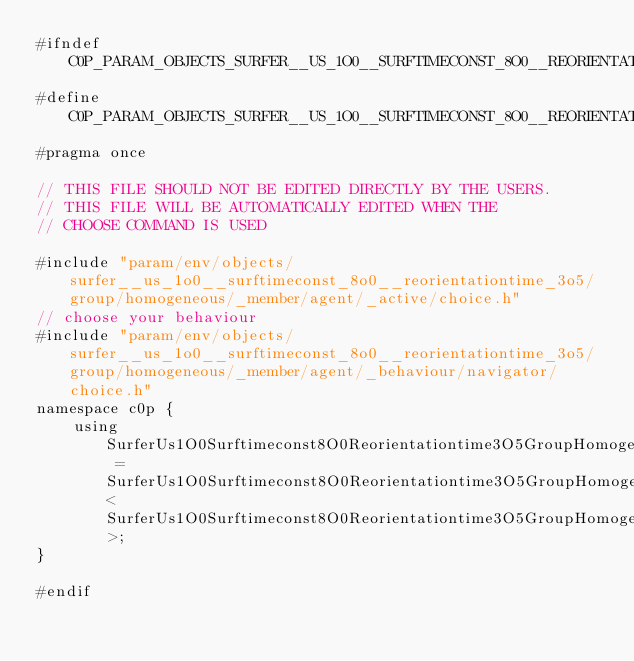Convert code to text. <code><loc_0><loc_0><loc_500><loc_500><_C_>#ifndef C0P_PARAM_OBJECTS_SURFER__US_1O0__SURFTIMECONST_8O0__REORIENTATIONTIME_3O5_GROUP_HOMOGENEOUS_MEMBER_AGENT_BEHAVIOUR_CHOICE_H
#define C0P_PARAM_OBJECTS_SURFER__US_1O0__SURFTIMECONST_8O0__REORIENTATIONTIME_3O5_GROUP_HOMOGENEOUS_MEMBER_AGENT_BEHAVIOUR_CHOICE_H
#pragma once

// THIS FILE SHOULD NOT BE EDITED DIRECTLY BY THE USERS.
// THIS FILE WILL BE AUTOMATICALLY EDITED WHEN THE
// CHOOSE COMMAND IS USED

#include "param/env/objects/surfer__us_1o0__surftimeconst_8o0__reorientationtime_3o5/group/homogeneous/_member/agent/_active/choice.h"
// choose your behaviour
#include "param/env/objects/surfer__us_1o0__surftimeconst_8o0__reorientationtime_3o5/group/homogeneous/_member/agent/_behaviour/navigator/choice.h"
namespace c0p {
    using SurferUs1O0Surftimeconst8O0Reorientationtime3O5GroupHomogeneousMemberAgentBehaviour = SurferUs1O0Surftimeconst8O0Reorientationtime3O5GroupHomogeneousMemberAgentBehaviourNavigator<SurferUs1O0Surftimeconst8O0Reorientationtime3O5GroupHomogeneousMemberAgentActiveStep>;
}

#endif
</code> 